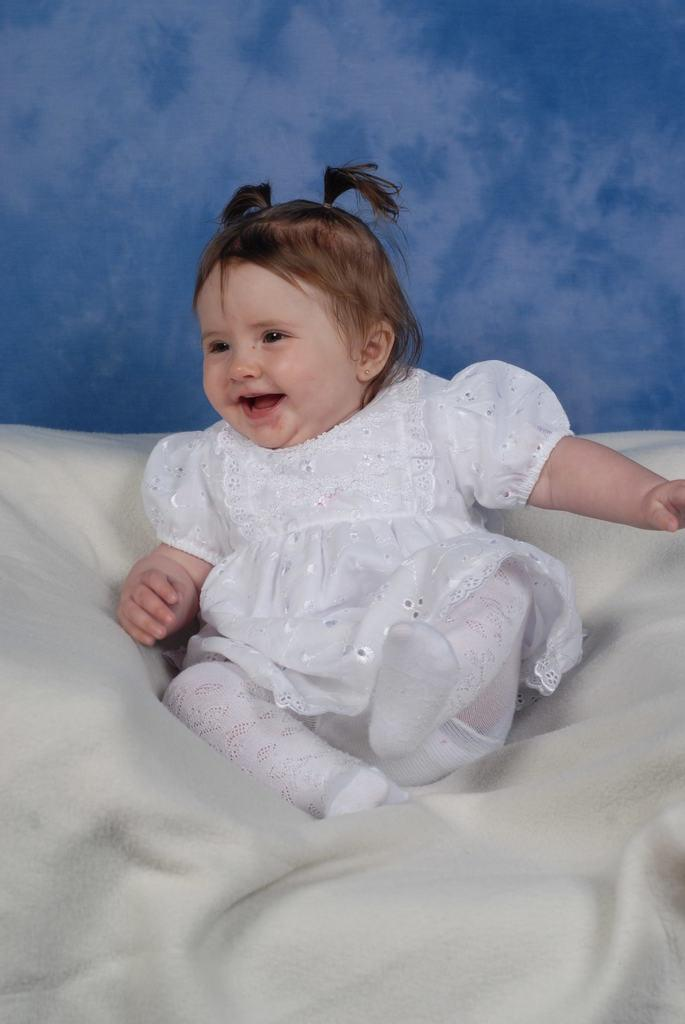Who is the main subject in the image? There is a girl in the image. What is the girl sitting on? The girl is sitting on a white color bed sheet. What color is the wall behind the girl? There is a blue color wall behind the girl. What type of temper can be seen in the girl's expression in the image? There is no indication of the girl's temper or expression in the image, as it only shows her sitting on a white bed sheet with a blue wall behind her. 